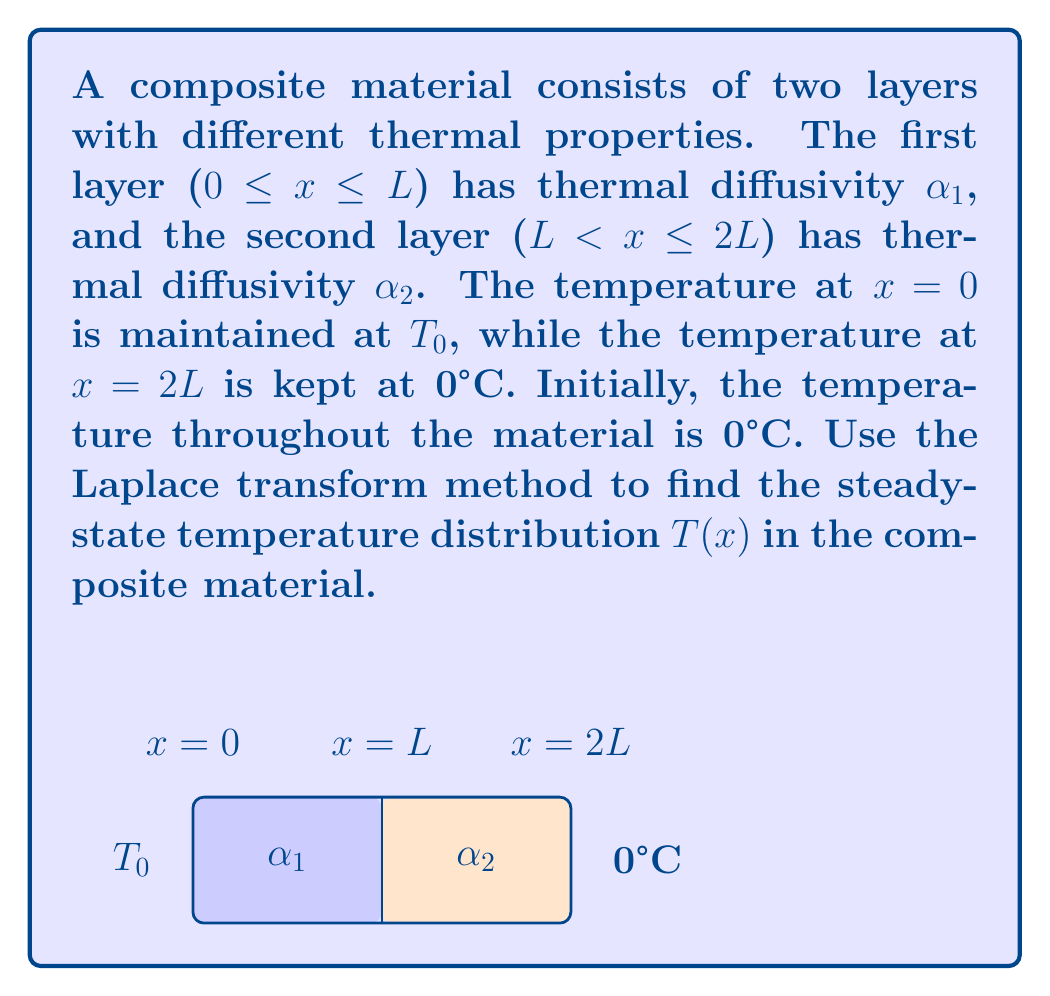Can you solve this math problem? To solve this problem using Laplace transforms, we'll follow these steps:

1) First, we need to write the heat equation for each layer:

   Layer 1 (0 ≤ x ≤ L): $\frac{\partial^2 T_1}{\partial x^2} = \frac{1}{\alpha_1}\frac{\partial T_1}{\partial t}$
   Layer 2 (L < x ≤ 2L): $\frac{\partial^2 T_2}{\partial x^2} = \frac{1}{\alpha_2}\frac{\partial T_2}{\partial t}$

2) Apply the Laplace transform to both equations with respect to t:

   $\frac{d^2 \bar{T_1}}{dx^2} = \frac{s}{\alpha_1}\bar{T_1}$
   $\frac{d^2 \bar{T_2}}{dx^2} = \frac{s}{\alpha_2}\bar{T_2}$

   Where $\bar{T}$ represents the Laplace transform of T.

3) The general solutions to these equations are:

   $\bar{T_1} = A_1e^{\sqrt{\frac{s}{\alpha_1}}x} + B_1e^{-\sqrt{\frac{s}{\alpha_1}}x}$
   $\bar{T_2} = A_2e^{\sqrt{\frac{s}{\alpha_2}}x} + B_2e^{-\sqrt{\frac{s}{\alpha_2}}x}$

4) Apply the boundary conditions:
   At x = 0: $\bar{T_1}(0,s) = \frac{T_0}{s}$
   At x = 2L: $\bar{T_2}(2L,s) = 0$

5) Apply the continuity conditions at x = L:
   $\bar{T_1}(L,s) = \bar{T_2}(L,s)$
   $k_1\frac{d\bar{T_1}}{dx}(L,s) = k_2\frac{d\bar{T_2}}{dx}(L,s)$

   Where k₁ and k₂ are the thermal conductivities of the two layers.

6) Solve the system of equations to find A₁, B₁, A₂, and B₂.

7) For the steady-state solution, we take the limit as s approaches 0:

   $T_1(x) = \lim_{s\to0} s\bar{T_1}(x,s)$
   $T_2(x) = \lim_{s\to0} s\bar{T_2}(x,s)$

8) After taking the limit, we get the steady-state solutions:

   $T_1(x) = T_0\frac{k_2(2L-x) + k_1x}{k_1L + k_2L}$ for 0 ≤ x ≤ L
   $T_2(x) = T_0\frac{k_2(2L-x)}{k_1L + k_2L}$ for L < x ≤ 2L

These equations represent the steady-state temperature distribution in the composite material.
Answer: $T(x) = \begin{cases} 
T_0\frac{k_2(2L-x) + k_1x}{k_1L + k_2L}, & 0 \leq x \leq L \\
T_0\frac{k_2(2L-x)}{k_1L + k_2L}, & L < x \leq 2L
\end{cases}$ 